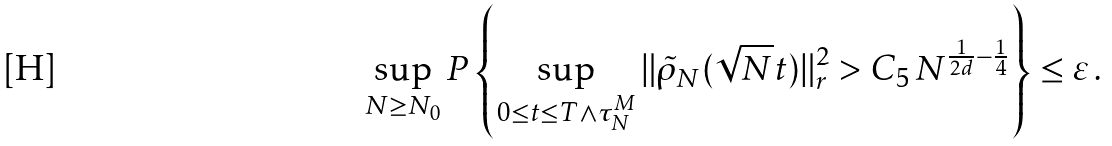<formula> <loc_0><loc_0><loc_500><loc_500>\sup _ { N \geq N _ { 0 } } P \left \{ \sup _ { 0 \leq t \leq T \wedge \tau _ { N } ^ { M } } \| \tilde { \rho } _ { N } ( \sqrt { N } t ) \| ^ { 2 } _ { r } > C _ { 5 } \, N ^ { \frac { 1 } { 2 d } - \frac { 1 } { 4 } } \right \} \leq \varepsilon \, .</formula> 